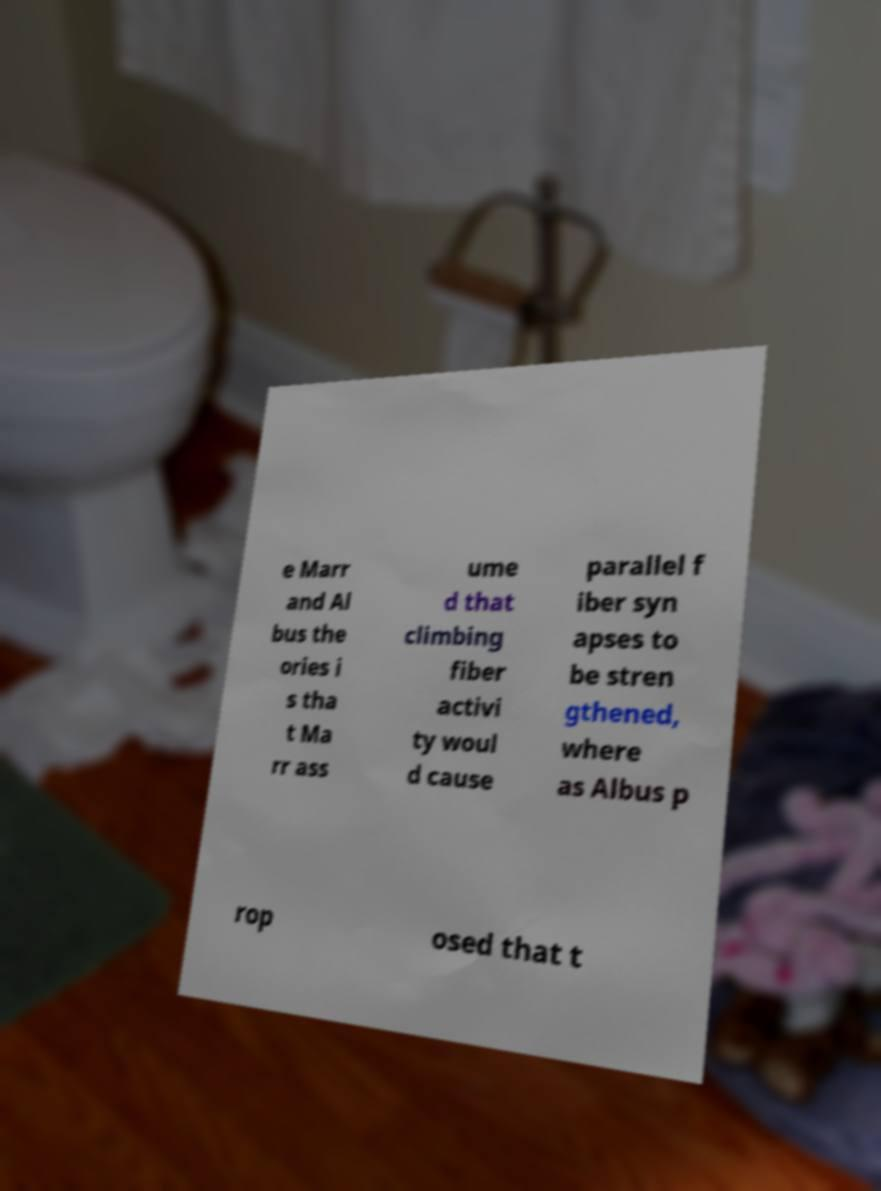Please read and relay the text visible in this image. What does it say? e Marr and Al bus the ories i s tha t Ma rr ass ume d that climbing fiber activi ty woul d cause parallel f iber syn apses to be stren gthened, where as Albus p rop osed that t 